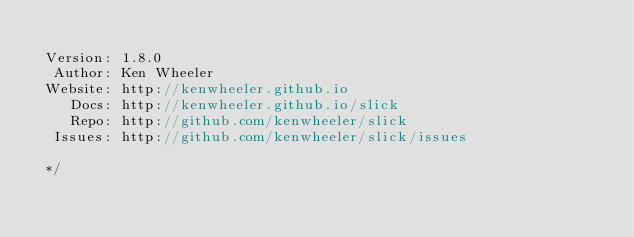Convert code to text. <code><loc_0><loc_0><loc_500><loc_500><_JavaScript_>
 Version: 1.8.0
  Author: Ken Wheeler
 Website: http://kenwheeler.github.io
    Docs: http://kenwheeler.github.io/slick
    Repo: http://github.com/kenwheeler/slick
  Issues: http://github.com/kenwheeler/slick/issues

 */</code> 